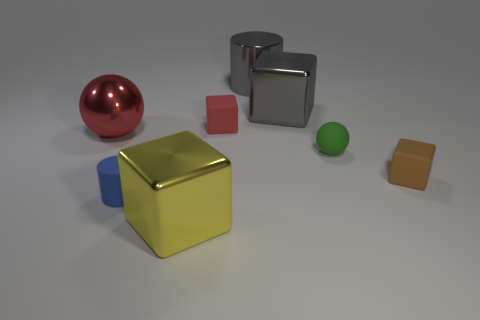Subtract 1 cubes. How many cubes are left? 3 Subtract all yellow cylinders. Subtract all green spheres. How many cylinders are left? 2 Add 1 tiny brown things. How many objects exist? 9 Subtract all cylinders. How many objects are left? 6 Add 7 tiny brown metal cylinders. How many tiny brown metal cylinders exist? 7 Subtract 1 green balls. How many objects are left? 7 Subtract all big gray metallic things. Subtract all yellow cylinders. How many objects are left? 6 Add 5 small matte balls. How many small matte balls are left? 6 